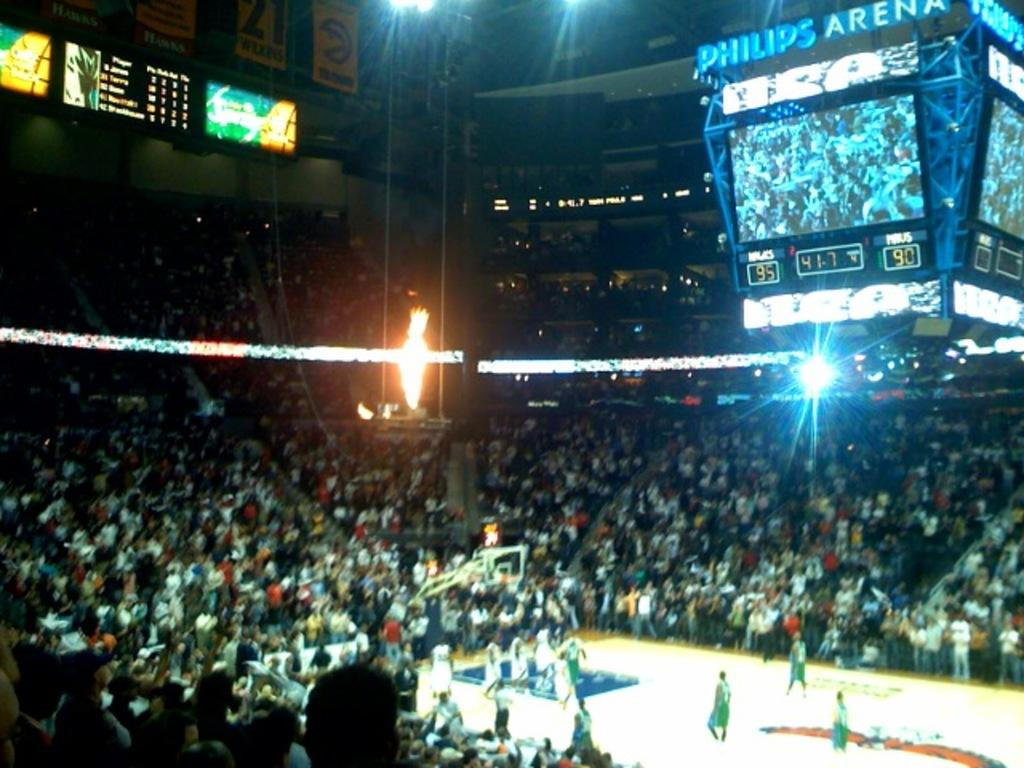<image>
Create a compact narrative representing the image presented. Basketball stadium that shows the scoreboard inside Philips Arena. 